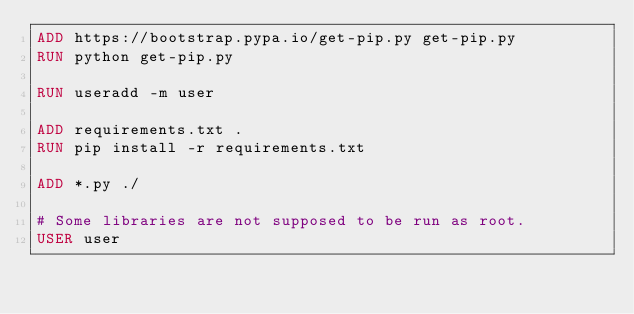<code> <loc_0><loc_0><loc_500><loc_500><_Dockerfile_>ADD https://bootstrap.pypa.io/get-pip.py get-pip.py
RUN python get-pip.py

RUN useradd -m user

ADD requirements.txt .
RUN pip install -r requirements.txt

ADD *.py ./

# Some libraries are not supposed to be run as root.
USER user</code> 